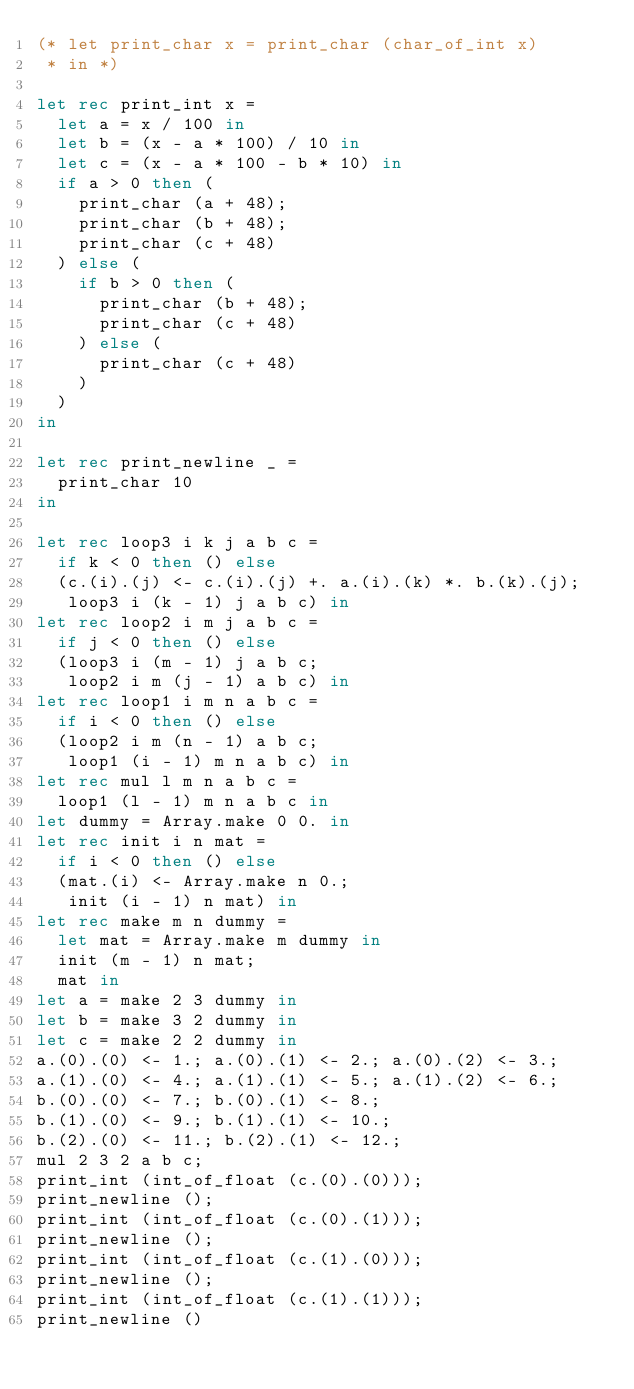<code> <loc_0><loc_0><loc_500><loc_500><_OCaml_>(* let print_char x = print_char (char_of_int x)
 * in *)

let rec print_int x =
  let a = x / 100 in
  let b = (x - a * 100) / 10 in
  let c = (x - a * 100 - b * 10) in
  if a > 0 then (
    print_char (a + 48);
    print_char (b + 48);
    print_char (c + 48)
  ) else (
    if b > 0 then (
      print_char (b + 48);
      print_char (c + 48)
    ) else (
      print_char (c + 48)
    )
  )
in

let rec print_newline _ =
  print_char 10
in

let rec loop3 i k j a b c =
  if k < 0 then () else
  (c.(i).(j) <- c.(i).(j) +. a.(i).(k) *. b.(k).(j);
   loop3 i (k - 1) j a b c) in
let rec loop2 i m j a b c =
  if j < 0 then () else
  (loop3 i (m - 1) j a b c;
   loop2 i m (j - 1) a b c) in
let rec loop1 i m n a b c =
  if i < 0 then () else
  (loop2 i m (n - 1) a b c;
   loop1 (i - 1) m n a b c) in
let rec mul l m n a b c =
  loop1 (l - 1) m n a b c in
let dummy = Array.make 0 0. in
let rec init i n mat =
  if i < 0 then () else
  (mat.(i) <- Array.make n 0.;
   init (i - 1) n mat) in
let rec make m n dummy =
  let mat = Array.make m dummy in
  init (m - 1) n mat;
  mat in
let a = make 2 3 dummy in
let b = make 3 2 dummy in
let c = make 2 2 dummy in
a.(0).(0) <- 1.; a.(0).(1) <- 2.; a.(0).(2) <- 3.;
a.(1).(0) <- 4.; a.(1).(1) <- 5.; a.(1).(2) <- 6.;
b.(0).(0) <- 7.; b.(0).(1) <- 8.;
b.(1).(0) <- 9.; b.(1).(1) <- 10.;
b.(2).(0) <- 11.; b.(2).(1) <- 12.;
mul 2 3 2 a b c;
print_int (int_of_float (c.(0).(0)));
print_newline ();
print_int (int_of_float (c.(0).(1)));
print_newline ();
print_int (int_of_float (c.(1).(0)));
print_newline ();
print_int (int_of_float (c.(1).(1)));
print_newline ()
</code> 